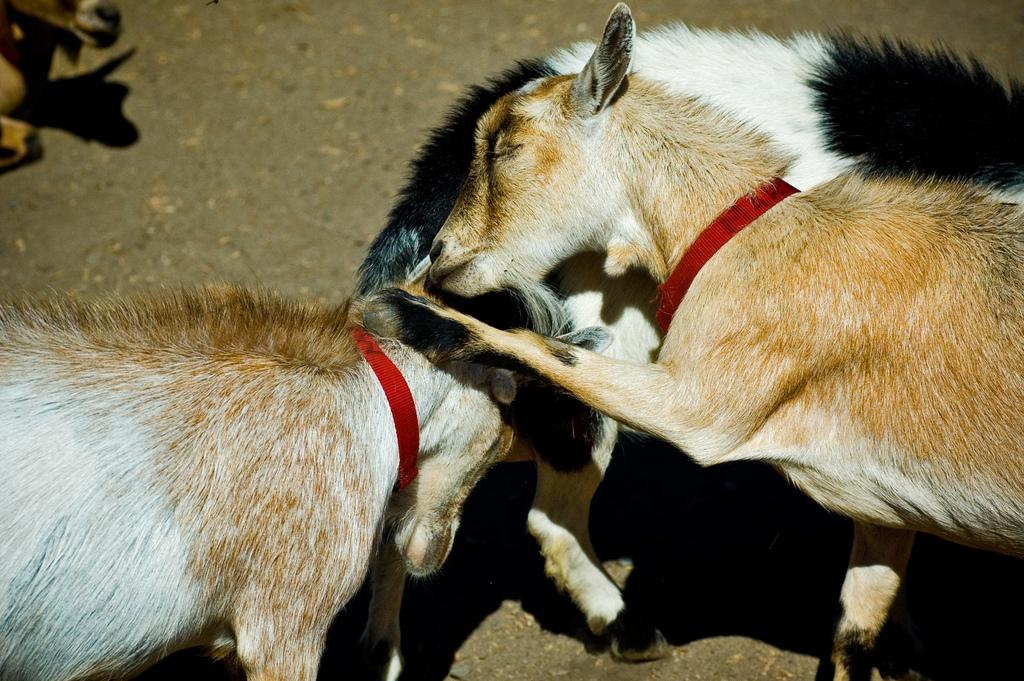What animals are present in the image? There are goats in the image. What is located at the bottom of the image? There is a road at the bottom of the image. How are the goats secured or restrained in the image? The goats are tied with red color belts. Are there any baseball players visible in the image? No, there are no baseball players present in the image. The image features goats and a road. 